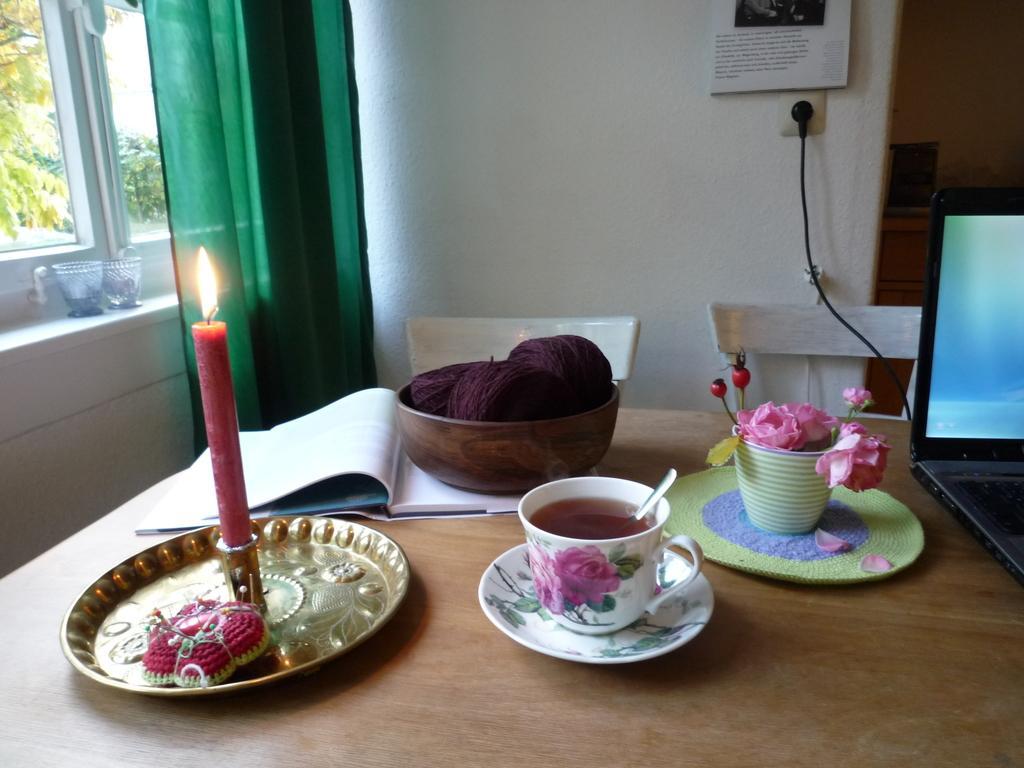Could you give a brief overview of what you see in this image? In this picture i could see a dining table on the dining table there is a cup filled with tea and spoon within it and a saucer under the cup and flower pot and flower carpet woolen thread holding in a bowl and a candle in on the plate. there is book on the table and a laptop also there are white colored chairs and green colored curtains of the picture and glass window with trees outside. 